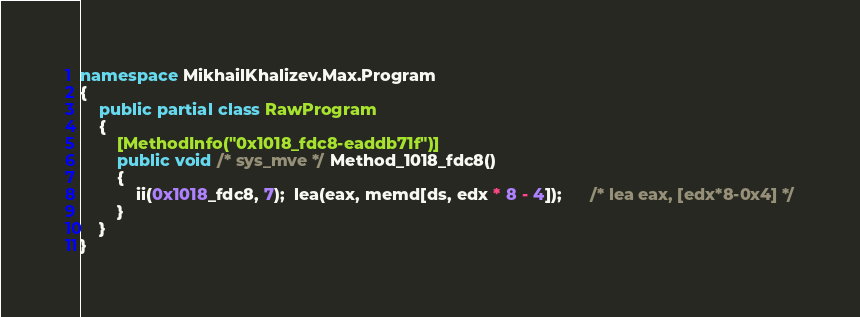Convert code to text. <code><loc_0><loc_0><loc_500><loc_500><_C#_>namespace MikhailKhalizev.Max.Program
{
    public partial class RawProgram
    {
        [MethodInfo("0x1018_fdc8-eaddb71f")]
        public void /* sys_mve */ Method_1018_fdc8()
        {
            ii(0x1018_fdc8, 7);  lea(eax, memd[ds, edx * 8 - 4]);      /* lea eax, [edx*8-0x4] */
        }
    }
}
</code> 